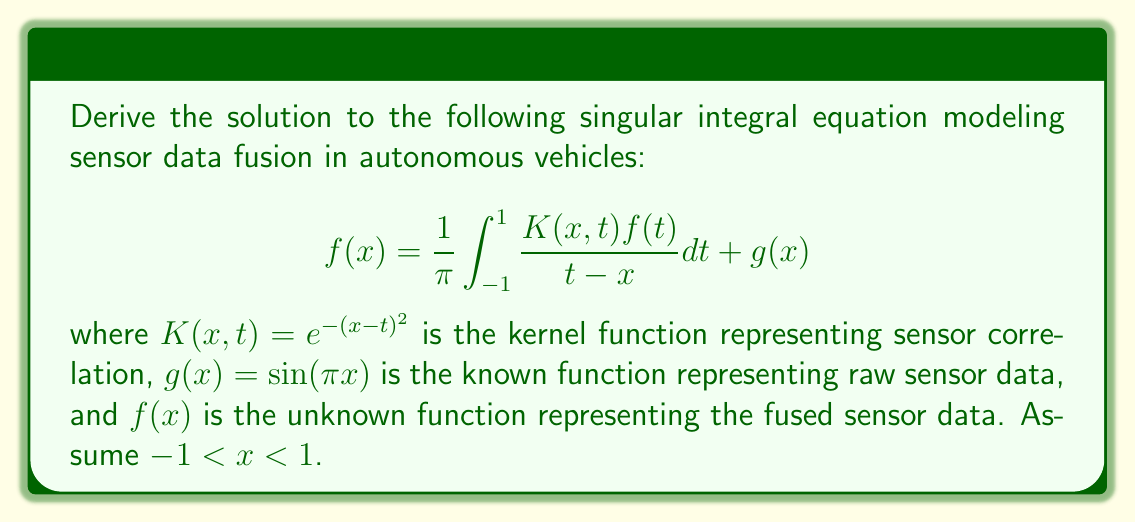Show me your answer to this math problem. To solve this singular integral equation, we'll use the following steps:

1) Recognize this as a Fredholm integral equation of the second kind with a Cauchy principal value integral.

2) Apply the Carleman-Vekua method to transform the equation:
   Let $f(x) = \omega(x)\phi(x)$, where $\omega(x) = \sqrt{1-x^2}$ is the weight function.

3) Substitute this into the original equation:
   $$\omega(x)\phi(x) = \frac{1}{\pi} \int_{-1}^{1} \frac{K(x,t)\omega(t)\phi(t)}{t-x} dt + g(x)$$

4) Divide both sides by $\omega(x)$:
   $$\phi(x) = \frac{1}{\pi\omega(x)} \int_{-1}^{1} \frac{K(x,t)\omega(t)\phi(t)}{t-x} dt + \frac{g(x)}{\omega(x)}$$

5) Define a new kernel:
   $$L(x,t) = \frac{K(x,t)\omega(t)}{\omega(x)} = \frac{e^{-(x-t)^2}\sqrt{1-t^2}}{\sqrt{1-x^2}}$$

6) Rewrite the equation:
   $$\phi(x) = \frac{1}{\pi} \int_{-1}^{1} \frac{L(x,t)\phi(t)}{t-x} dt + \frac{g(x)}{\omega(x)}$$

7) This is now a regular Fredholm equation of the second kind. We can solve it using the Neumann series method:
   $$\phi(x) = \sum_{n=0}^{\infty} \phi_n(x)$$
   where $\phi_0(x) = \frac{g(x)}{\omega(x)}$ and
   $$\phi_{n+1}(x) = \frac{1}{\pi} \int_{-1}^{1} \frac{L(x,t)\phi_n(t)}{t-x} dt$$

8) The solution converges rapidly due to the exponential decay in the kernel. We can approximate it with the first few terms:
   $$\phi(x) \approx \phi_0(x) + \phi_1(x) + \phi_2(x)$$

9) Finally, we obtain the solution:
   $$f(x) = \omega(x)\phi(x) = \sqrt{1-x^2}(\phi_0(x) + \phi_1(x) + \phi_2(x))$$

Due to the complexity of the integrals involved, the exact closed-form solution is not feasible. Numerical methods would be used to evaluate the integrals in practice.
Answer: $f(x) = \sqrt{1-x^2}(\phi_0(x) + \phi_1(x) + \phi_2(x))$, where $\phi_0(x) = \frac{\sin(\pi x)}{\sqrt{1-x^2}}$ and $\phi_{n+1}(x) = \frac{1}{\pi} \int_{-1}^{1} \frac{L(x,t)\phi_n(t)}{t-x} dt$ with $L(x,t) = \frac{e^{-(x-t)^2}\sqrt{1-t^2}}{\sqrt{1-x^2}}$. 